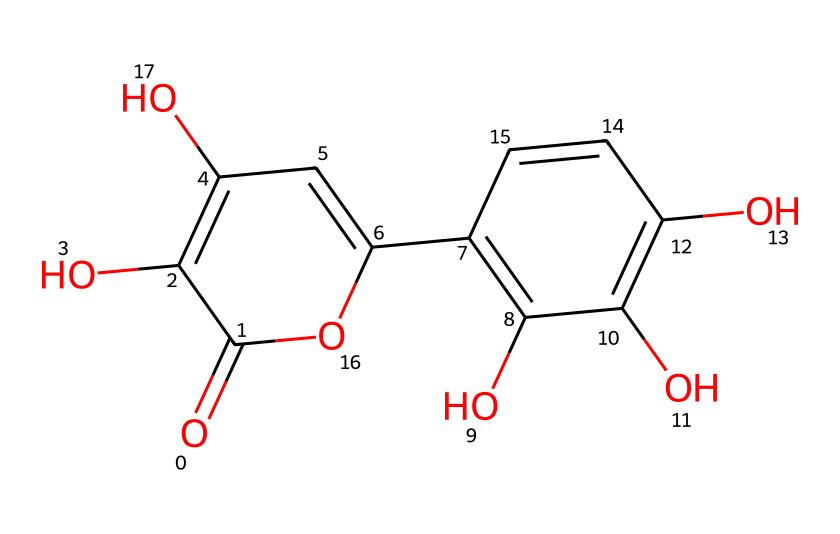How many hydroxyl groups are present in quercetin? Quercetin has three hydroxyl groups (the -OH groups) indicated in its structure. By examining the representation, we can identify three distinct -OH groups attached to the aromatic rings.
Answer: 3 What is the molecular weight of quercetin? To find the molecular weight, we can analyze the atoms present in the chemical structure and sum their weights. The precise molecular formula for quercetin is C15H10O7, and its molecular weight is approximately 302.24 g/mol.
Answer: 302.24 g/mol How many aromatic rings are in the structure of quercetin? Analyzing the structure, we see that there are two distinct aromatic rings in quercetin. They can be identified by the alternating double bonds and the planar nature of the associated carbon atoms.
Answer: 2 Does quercetin contain any carbonyl groups? Looking at the structure, we can identify one carbonyl group (C=O) in the molecule, which is placed as part of the carbon chain.
Answer: Yes What type of chemical is quercetin classified as? Quercetin is classified as a flavonoid, which is a type of phenolic compound. By analyzing its structure and recognizing the presence of multiple hydroxyl groups and aromatic characteristics, we can confirm its classification.
Answer: flavonoid 